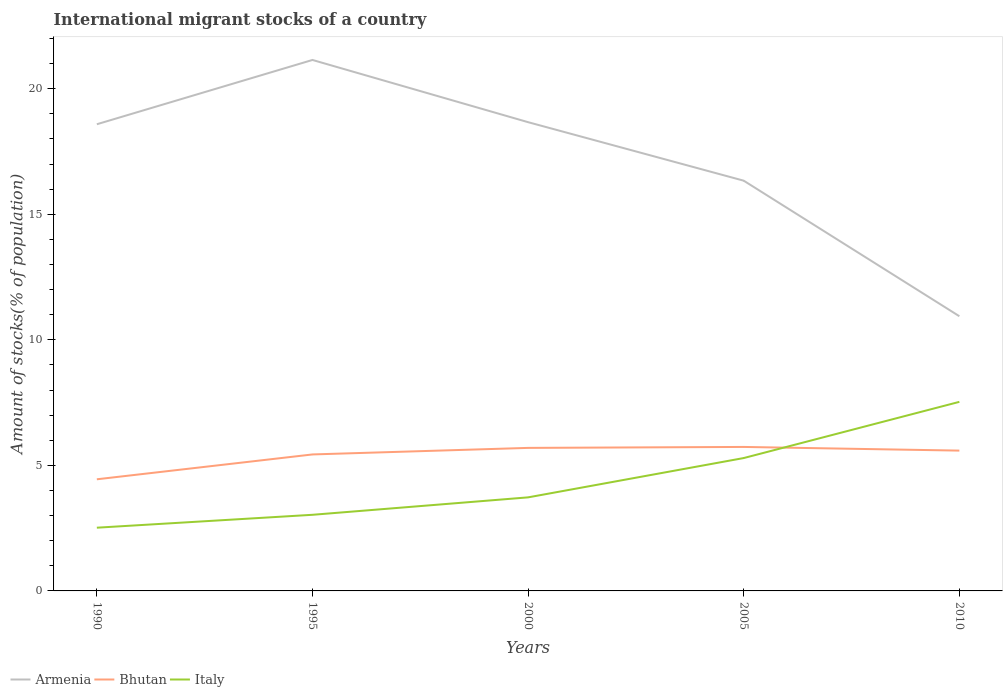Is the number of lines equal to the number of legend labels?
Your answer should be compact. Yes. Across all years, what is the maximum amount of stocks in in Bhutan?
Offer a terse response. 4.45. In which year was the amount of stocks in in Italy maximum?
Make the answer very short. 1990. What is the total amount of stocks in in Armenia in the graph?
Offer a very short reply. -2.56. What is the difference between the highest and the second highest amount of stocks in in Italy?
Your answer should be compact. 5.01. How many years are there in the graph?
Your answer should be compact. 5. What is the difference between two consecutive major ticks on the Y-axis?
Keep it short and to the point. 5. Are the values on the major ticks of Y-axis written in scientific E-notation?
Ensure brevity in your answer.  No. Does the graph contain any zero values?
Your answer should be compact. No. Where does the legend appear in the graph?
Your answer should be very brief. Bottom left. How many legend labels are there?
Your answer should be very brief. 3. How are the legend labels stacked?
Provide a succinct answer. Horizontal. What is the title of the graph?
Keep it short and to the point. International migrant stocks of a country. What is the label or title of the Y-axis?
Provide a succinct answer. Amount of stocks(% of population). What is the Amount of stocks(% of population) in Armenia in 1990?
Keep it short and to the point. 18.59. What is the Amount of stocks(% of population) of Bhutan in 1990?
Offer a terse response. 4.45. What is the Amount of stocks(% of population) in Italy in 1990?
Ensure brevity in your answer.  2.52. What is the Amount of stocks(% of population) in Armenia in 1995?
Make the answer very short. 21.15. What is the Amount of stocks(% of population) in Bhutan in 1995?
Keep it short and to the point. 5.44. What is the Amount of stocks(% of population) in Italy in 1995?
Ensure brevity in your answer.  3.03. What is the Amount of stocks(% of population) of Armenia in 2000?
Provide a short and direct response. 18.67. What is the Amount of stocks(% of population) of Bhutan in 2000?
Provide a short and direct response. 5.7. What is the Amount of stocks(% of population) of Italy in 2000?
Keep it short and to the point. 3.73. What is the Amount of stocks(% of population) of Armenia in 2005?
Your answer should be very brief. 16.34. What is the Amount of stocks(% of population) in Bhutan in 2005?
Your answer should be compact. 5.73. What is the Amount of stocks(% of population) in Italy in 2005?
Your response must be concise. 5.29. What is the Amount of stocks(% of population) in Armenia in 2010?
Your response must be concise. 10.94. What is the Amount of stocks(% of population) in Bhutan in 2010?
Provide a succinct answer. 5.59. What is the Amount of stocks(% of population) in Italy in 2010?
Your answer should be compact. 7.53. Across all years, what is the maximum Amount of stocks(% of population) in Armenia?
Give a very brief answer. 21.15. Across all years, what is the maximum Amount of stocks(% of population) in Bhutan?
Ensure brevity in your answer.  5.73. Across all years, what is the maximum Amount of stocks(% of population) in Italy?
Provide a short and direct response. 7.53. Across all years, what is the minimum Amount of stocks(% of population) in Armenia?
Your answer should be compact. 10.94. Across all years, what is the minimum Amount of stocks(% of population) of Bhutan?
Offer a terse response. 4.45. Across all years, what is the minimum Amount of stocks(% of population) of Italy?
Offer a very short reply. 2.52. What is the total Amount of stocks(% of population) of Armenia in the graph?
Your answer should be compact. 85.68. What is the total Amount of stocks(% of population) of Bhutan in the graph?
Provide a succinct answer. 26.9. What is the total Amount of stocks(% of population) in Italy in the graph?
Offer a very short reply. 22.1. What is the difference between the Amount of stocks(% of population) in Armenia in 1990 and that in 1995?
Give a very brief answer. -2.56. What is the difference between the Amount of stocks(% of population) of Bhutan in 1990 and that in 1995?
Your answer should be very brief. -0.99. What is the difference between the Amount of stocks(% of population) in Italy in 1990 and that in 1995?
Keep it short and to the point. -0.51. What is the difference between the Amount of stocks(% of population) in Armenia in 1990 and that in 2000?
Your answer should be very brief. -0.08. What is the difference between the Amount of stocks(% of population) in Bhutan in 1990 and that in 2000?
Keep it short and to the point. -1.25. What is the difference between the Amount of stocks(% of population) of Italy in 1990 and that in 2000?
Keep it short and to the point. -1.21. What is the difference between the Amount of stocks(% of population) of Armenia in 1990 and that in 2005?
Your answer should be compact. 2.25. What is the difference between the Amount of stocks(% of population) in Bhutan in 1990 and that in 2005?
Give a very brief answer. -1.29. What is the difference between the Amount of stocks(% of population) in Italy in 1990 and that in 2005?
Offer a terse response. -2.77. What is the difference between the Amount of stocks(% of population) in Armenia in 1990 and that in 2010?
Provide a succinct answer. 7.65. What is the difference between the Amount of stocks(% of population) in Bhutan in 1990 and that in 2010?
Keep it short and to the point. -1.14. What is the difference between the Amount of stocks(% of population) in Italy in 1990 and that in 2010?
Offer a terse response. -5.01. What is the difference between the Amount of stocks(% of population) in Armenia in 1995 and that in 2000?
Provide a short and direct response. 2.48. What is the difference between the Amount of stocks(% of population) in Bhutan in 1995 and that in 2000?
Provide a succinct answer. -0.26. What is the difference between the Amount of stocks(% of population) in Italy in 1995 and that in 2000?
Ensure brevity in your answer.  -0.69. What is the difference between the Amount of stocks(% of population) of Armenia in 1995 and that in 2005?
Your answer should be very brief. 4.81. What is the difference between the Amount of stocks(% of population) in Bhutan in 1995 and that in 2005?
Make the answer very short. -0.3. What is the difference between the Amount of stocks(% of population) of Italy in 1995 and that in 2005?
Keep it short and to the point. -2.26. What is the difference between the Amount of stocks(% of population) of Armenia in 1995 and that in 2010?
Ensure brevity in your answer.  10.21. What is the difference between the Amount of stocks(% of population) in Bhutan in 1995 and that in 2010?
Make the answer very short. -0.15. What is the difference between the Amount of stocks(% of population) of Italy in 1995 and that in 2010?
Make the answer very short. -4.5. What is the difference between the Amount of stocks(% of population) in Armenia in 2000 and that in 2005?
Provide a succinct answer. 2.33. What is the difference between the Amount of stocks(% of population) in Bhutan in 2000 and that in 2005?
Give a very brief answer. -0.04. What is the difference between the Amount of stocks(% of population) of Italy in 2000 and that in 2005?
Your answer should be compact. -1.57. What is the difference between the Amount of stocks(% of population) in Armenia in 2000 and that in 2010?
Make the answer very short. 7.73. What is the difference between the Amount of stocks(% of population) of Bhutan in 2000 and that in 2010?
Give a very brief answer. 0.11. What is the difference between the Amount of stocks(% of population) of Italy in 2000 and that in 2010?
Your answer should be compact. -3.8. What is the difference between the Amount of stocks(% of population) of Armenia in 2005 and that in 2010?
Your answer should be very brief. 5.4. What is the difference between the Amount of stocks(% of population) of Bhutan in 2005 and that in 2010?
Offer a terse response. 0.15. What is the difference between the Amount of stocks(% of population) in Italy in 2005 and that in 2010?
Your answer should be compact. -2.24. What is the difference between the Amount of stocks(% of population) in Armenia in 1990 and the Amount of stocks(% of population) in Bhutan in 1995?
Make the answer very short. 13.15. What is the difference between the Amount of stocks(% of population) of Armenia in 1990 and the Amount of stocks(% of population) of Italy in 1995?
Keep it short and to the point. 15.55. What is the difference between the Amount of stocks(% of population) in Bhutan in 1990 and the Amount of stocks(% of population) in Italy in 1995?
Make the answer very short. 1.41. What is the difference between the Amount of stocks(% of population) in Armenia in 1990 and the Amount of stocks(% of population) in Bhutan in 2000?
Ensure brevity in your answer.  12.89. What is the difference between the Amount of stocks(% of population) in Armenia in 1990 and the Amount of stocks(% of population) in Italy in 2000?
Make the answer very short. 14.86. What is the difference between the Amount of stocks(% of population) of Bhutan in 1990 and the Amount of stocks(% of population) of Italy in 2000?
Keep it short and to the point. 0.72. What is the difference between the Amount of stocks(% of population) in Armenia in 1990 and the Amount of stocks(% of population) in Bhutan in 2005?
Make the answer very short. 12.85. What is the difference between the Amount of stocks(% of population) of Armenia in 1990 and the Amount of stocks(% of population) of Italy in 2005?
Keep it short and to the point. 13.29. What is the difference between the Amount of stocks(% of population) of Bhutan in 1990 and the Amount of stocks(% of population) of Italy in 2005?
Provide a short and direct response. -0.85. What is the difference between the Amount of stocks(% of population) of Armenia in 1990 and the Amount of stocks(% of population) of Bhutan in 2010?
Offer a terse response. 13. What is the difference between the Amount of stocks(% of population) in Armenia in 1990 and the Amount of stocks(% of population) in Italy in 2010?
Make the answer very short. 11.06. What is the difference between the Amount of stocks(% of population) of Bhutan in 1990 and the Amount of stocks(% of population) of Italy in 2010?
Provide a succinct answer. -3.08. What is the difference between the Amount of stocks(% of population) in Armenia in 1995 and the Amount of stocks(% of population) in Bhutan in 2000?
Make the answer very short. 15.45. What is the difference between the Amount of stocks(% of population) in Armenia in 1995 and the Amount of stocks(% of population) in Italy in 2000?
Your answer should be compact. 17.42. What is the difference between the Amount of stocks(% of population) in Bhutan in 1995 and the Amount of stocks(% of population) in Italy in 2000?
Make the answer very short. 1.71. What is the difference between the Amount of stocks(% of population) of Armenia in 1995 and the Amount of stocks(% of population) of Bhutan in 2005?
Your answer should be very brief. 15.41. What is the difference between the Amount of stocks(% of population) of Armenia in 1995 and the Amount of stocks(% of population) of Italy in 2005?
Ensure brevity in your answer.  15.85. What is the difference between the Amount of stocks(% of population) of Bhutan in 1995 and the Amount of stocks(% of population) of Italy in 2005?
Make the answer very short. 0.14. What is the difference between the Amount of stocks(% of population) in Armenia in 1995 and the Amount of stocks(% of population) in Bhutan in 2010?
Make the answer very short. 15.56. What is the difference between the Amount of stocks(% of population) in Armenia in 1995 and the Amount of stocks(% of population) in Italy in 2010?
Give a very brief answer. 13.62. What is the difference between the Amount of stocks(% of population) of Bhutan in 1995 and the Amount of stocks(% of population) of Italy in 2010?
Ensure brevity in your answer.  -2.09. What is the difference between the Amount of stocks(% of population) of Armenia in 2000 and the Amount of stocks(% of population) of Bhutan in 2005?
Keep it short and to the point. 12.93. What is the difference between the Amount of stocks(% of population) in Armenia in 2000 and the Amount of stocks(% of population) in Italy in 2005?
Your answer should be compact. 13.38. What is the difference between the Amount of stocks(% of population) in Bhutan in 2000 and the Amount of stocks(% of population) in Italy in 2005?
Your response must be concise. 0.4. What is the difference between the Amount of stocks(% of population) of Armenia in 2000 and the Amount of stocks(% of population) of Bhutan in 2010?
Ensure brevity in your answer.  13.08. What is the difference between the Amount of stocks(% of population) of Armenia in 2000 and the Amount of stocks(% of population) of Italy in 2010?
Keep it short and to the point. 11.14. What is the difference between the Amount of stocks(% of population) of Bhutan in 2000 and the Amount of stocks(% of population) of Italy in 2010?
Offer a terse response. -1.83. What is the difference between the Amount of stocks(% of population) in Armenia in 2005 and the Amount of stocks(% of population) in Bhutan in 2010?
Provide a short and direct response. 10.75. What is the difference between the Amount of stocks(% of population) of Armenia in 2005 and the Amount of stocks(% of population) of Italy in 2010?
Provide a short and direct response. 8.81. What is the difference between the Amount of stocks(% of population) of Bhutan in 2005 and the Amount of stocks(% of population) of Italy in 2010?
Your response must be concise. -1.8. What is the average Amount of stocks(% of population) in Armenia per year?
Make the answer very short. 17.14. What is the average Amount of stocks(% of population) in Bhutan per year?
Offer a terse response. 5.38. What is the average Amount of stocks(% of population) of Italy per year?
Give a very brief answer. 4.42. In the year 1990, what is the difference between the Amount of stocks(% of population) in Armenia and Amount of stocks(% of population) in Bhutan?
Make the answer very short. 14.14. In the year 1990, what is the difference between the Amount of stocks(% of population) in Armenia and Amount of stocks(% of population) in Italy?
Your answer should be very brief. 16.07. In the year 1990, what is the difference between the Amount of stocks(% of population) of Bhutan and Amount of stocks(% of population) of Italy?
Your answer should be compact. 1.93. In the year 1995, what is the difference between the Amount of stocks(% of population) in Armenia and Amount of stocks(% of population) in Bhutan?
Offer a very short reply. 15.71. In the year 1995, what is the difference between the Amount of stocks(% of population) of Armenia and Amount of stocks(% of population) of Italy?
Your answer should be compact. 18.11. In the year 1995, what is the difference between the Amount of stocks(% of population) of Bhutan and Amount of stocks(% of population) of Italy?
Offer a terse response. 2.4. In the year 2000, what is the difference between the Amount of stocks(% of population) in Armenia and Amount of stocks(% of population) in Bhutan?
Your answer should be compact. 12.97. In the year 2000, what is the difference between the Amount of stocks(% of population) in Armenia and Amount of stocks(% of population) in Italy?
Offer a very short reply. 14.94. In the year 2000, what is the difference between the Amount of stocks(% of population) in Bhutan and Amount of stocks(% of population) in Italy?
Give a very brief answer. 1.97. In the year 2005, what is the difference between the Amount of stocks(% of population) in Armenia and Amount of stocks(% of population) in Bhutan?
Give a very brief answer. 10.6. In the year 2005, what is the difference between the Amount of stocks(% of population) of Armenia and Amount of stocks(% of population) of Italy?
Make the answer very short. 11.05. In the year 2005, what is the difference between the Amount of stocks(% of population) in Bhutan and Amount of stocks(% of population) in Italy?
Make the answer very short. 0.44. In the year 2010, what is the difference between the Amount of stocks(% of population) of Armenia and Amount of stocks(% of population) of Bhutan?
Give a very brief answer. 5.35. In the year 2010, what is the difference between the Amount of stocks(% of population) of Armenia and Amount of stocks(% of population) of Italy?
Make the answer very short. 3.41. In the year 2010, what is the difference between the Amount of stocks(% of population) of Bhutan and Amount of stocks(% of population) of Italy?
Your answer should be compact. -1.94. What is the ratio of the Amount of stocks(% of population) in Armenia in 1990 to that in 1995?
Offer a very short reply. 0.88. What is the ratio of the Amount of stocks(% of population) in Bhutan in 1990 to that in 1995?
Your answer should be very brief. 0.82. What is the ratio of the Amount of stocks(% of population) of Italy in 1990 to that in 1995?
Give a very brief answer. 0.83. What is the ratio of the Amount of stocks(% of population) in Bhutan in 1990 to that in 2000?
Give a very brief answer. 0.78. What is the ratio of the Amount of stocks(% of population) in Italy in 1990 to that in 2000?
Your answer should be very brief. 0.68. What is the ratio of the Amount of stocks(% of population) in Armenia in 1990 to that in 2005?
Make the answer very short. 1.14. What is the ratio of the Amount of stocks(% of population) in Bhutan in 1990 to that in 2005?
Ensure brevity in your answer.  0.78. What is the ratio of the Amount of stocks(% of population) of Italy in 1990 to that in 2005?
Keep it short and to the point. 0.48. What is the ratio of the Amount of stocks(% of population) of Armenia in 1990 to that in 2010?
Offer a terse response. 1.7. What is the ratio of the Amount of stocks(% of population) in Bhutan in 1990 to that in 2010?
Ensure brevity in your answer.  0.8. What is the ratio of the Amount of stocks(% of population) of Italy in 1990 to that in 2010?
Give a very brief answer. 0.33. What is the ratio of the Amount of stocks(% of population) in Armenia in 1995 to that in 2000?
Keep it short and to the point. 1.13. What is the ratio of the Amount of stocks(% of population) in Bhutan in 1995 to that in 2000?
Your answer should be very brief. 0.95. What is the ratio of the Amount of stocks(% of population) of Italy in 1995 to that in 2000?
Keep it short and to the point. 0.81. What is the ratio of the Amount of stocks(% of population) in Armenia in 1995 to that in 2005?
Make the answer very short. 1.29. What is the ratio of the Amount of stocks(% of population) in Bhutan in 1995 to that in 2005?
Make the answer very short. 0.95. What is the ratio of the Amount of stocks(% of population) in Italy in 1995 to that in 2005?
Offer a very short reply. 0.57. What is the ratio of the Amount of stocks(% of population) of Armenia in 1995 to that in 2010?
Offer a terse response. 1.93. What is the ratio of the Amount of stocks(% of population) of Bhutan in 1995 to that in 2010?
Offer a very short reply. 0.97. What is the ratio of the Amount of stocks(% of population) of Italy in 1995 to that in 2010?
Provide a short and direct response. 0.4. What is the ratio of the Amount of stocks(% of population) of Armenia in 2000 to that in 2005?
Offer a terse response. 1.14. What is the ratio of the Amount of stocks(% of population) in Bhutan in 2000 to that in 2005?
Provide a short and direct response. 0.99. What is the ratio of the Amount of stocks(% of population) of Italy in 2000 to that in 2005?
Make the answer very short. 0.7. What is the ratio of the Amount of stocks(% of population) of Armenia in 2000 to that in 2010?
Your answer should be compact. 1.71. What is the ratio of the Amount of stocks(% of population) of Bhutan in 2000 to that in 2010?
Your answer should be very brief. 1.02. What is the ratio of the Amount of stocks(% of population) in Italy in 2000 to that in 2010?
Your response must be concise. 0.49. What is the ratio of the Amount of stocks(% of population) in Armenia in 2005 to that in 2010?
Give a very brief answer. 1.49. What is the ratio of the Amount of stocks(% of population) of Bhutan in 2005 to that in 2010?
Provide a succinct answer. 1.03. What is the ratio of the Amount of stocks(% of population) in Italy in 2005 to that in 2010?
Provide a short and direct response. 0.7. What is the difference between the highest and the second highest Amount of stocks(% of population) of Armenia?
Make the answer very short. 2.48. What is the difference between the highest and the second highest Amount of stocks(% of population) of Bhutan?
Your response must be concise. 0.04. What is the difference between the highest and the second highest Amount of stocks(% of population) in Italy?
Offer a very short reply. 2.24. What is the difference between the highest and the lowest Amount of stocks(% of population) in Armenia?
Offer a terse response. 10.21. What is the difference between the highest and the lowest Amount of stocks(% of population) of Bhutan?
Your answer should be compact. 1.29. What is the difference between the highest and the lowest Amount of stocks(% of population) in Italy?
Provide a succinct answer. 5.01. 